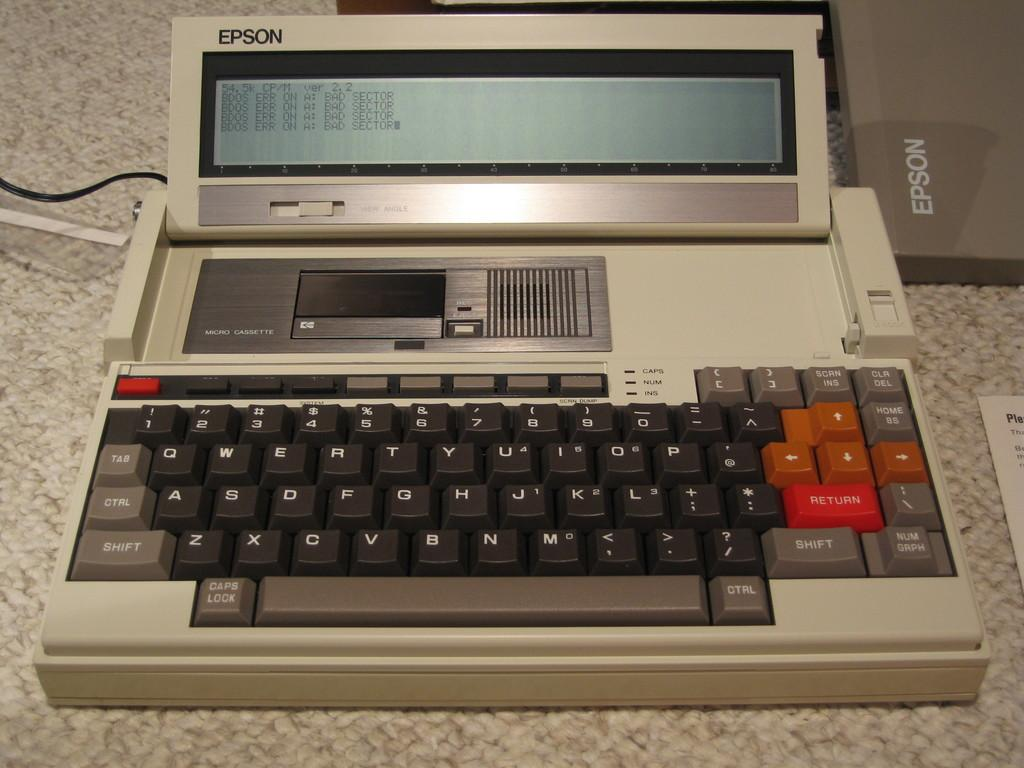<image>
Relay a brief, clear account of the picture shown. A vintage Epson brand micro cassette player sits on a counter. 